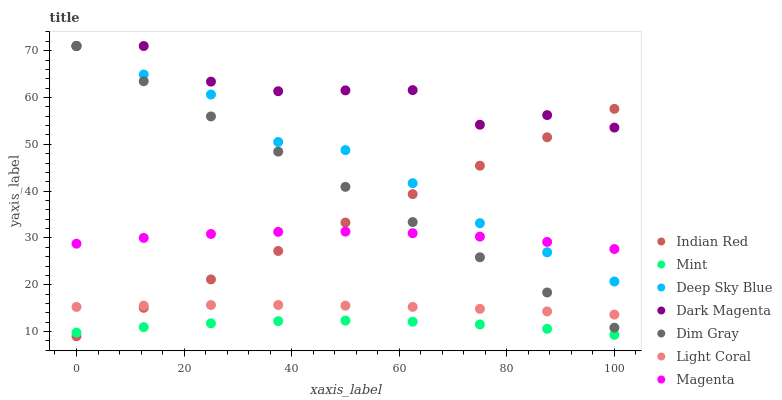Does Mint have the minimum area under the curve?
Answer yes or no. Yes. Does Dark Magenta have the maximum area under the curve?
Answer yes or no. Yes. Does Indian Red have the minimum area under the curve?
Answer yes or no. No. Does Indian Red have the maximum area under the curve?
Answer yes or no. No. Is Dim Gray the smoothest?
Answer yes or no. Yes. Is Dark Magenta the roughest?
Answer yes or no. Yes. Is Indian Red the smoothest?
Answer yes or no. No. Is Indian Red the roughest?
Answer yes or no. No. Does Indian Red have the lowest value?
Answer yes or no. Yes. Does Light Coral have the lowest value?
Answer yes or no. No. Does Dark Magenta have the highest value?
Answer yes or no. Yes. Does Indian Red have the highest value?
Answer yes or no. No. Is Mint less than Light Coral?
Answer yes or no. Yes. Is Dark Magenta greater than Magenta?
Answer yes or no. Yes. Does Deep Sky Blue intersect Dark Magenta?
Answer yes or no. Yes. Is Deep Sky Blue less than Dark Magenta?
Answer yes or no. No. Is Deep Sky Blue greater than Dark Magenta?
Answer yes or no. No. Does Mint intersect Light Coral?
Answer yes or no. No. 